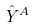<formula> <loc_0><loc_0><loc_500><loc_500>\hat { Y } ^ { A }</formula> 